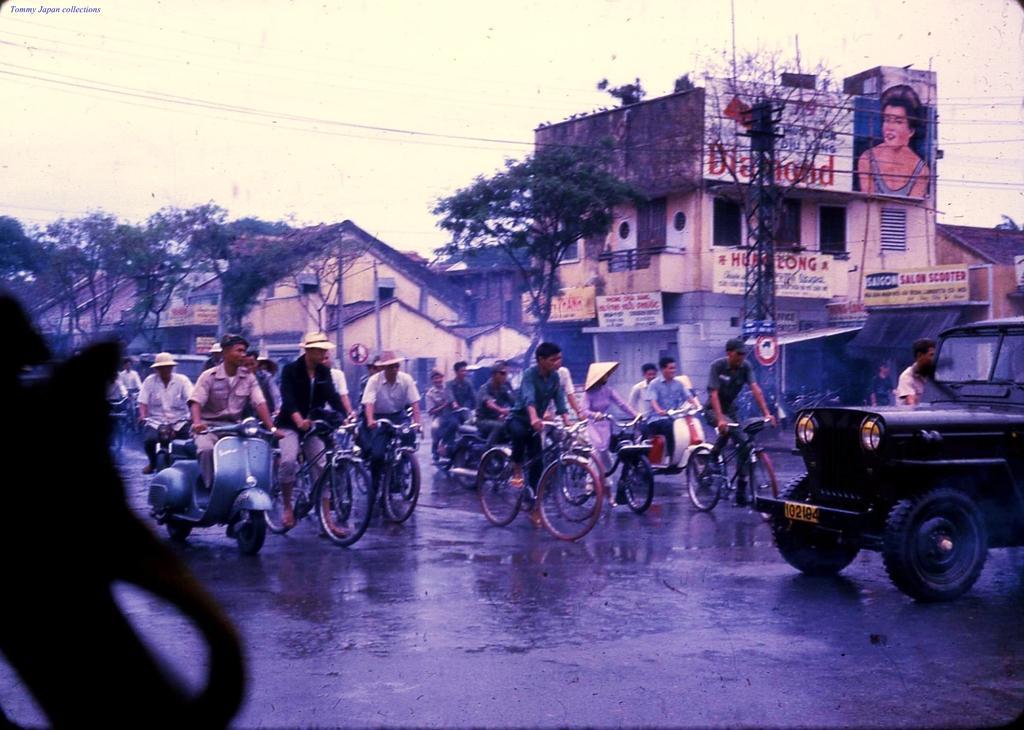Describe this image in one or two sentences. There are people on the road riding vehicles. In the background there are buildings,trees,pole,sign board,hoardings and sky. 